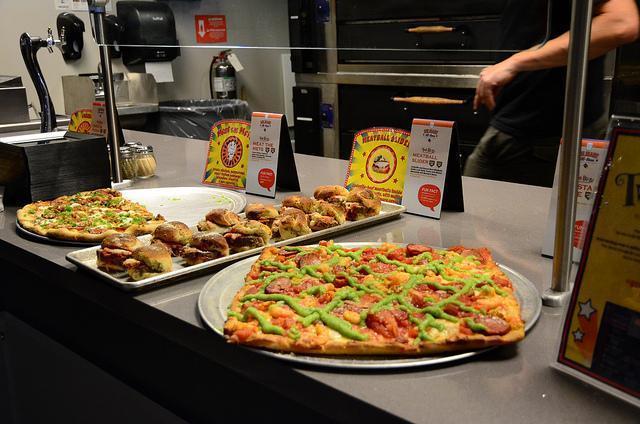How many pizzas?
Give a very brief answer. 2. How many ovens are there?
Give a very brief answer. 2. How many pizzas are there?
Give a very brief answer. 2. 